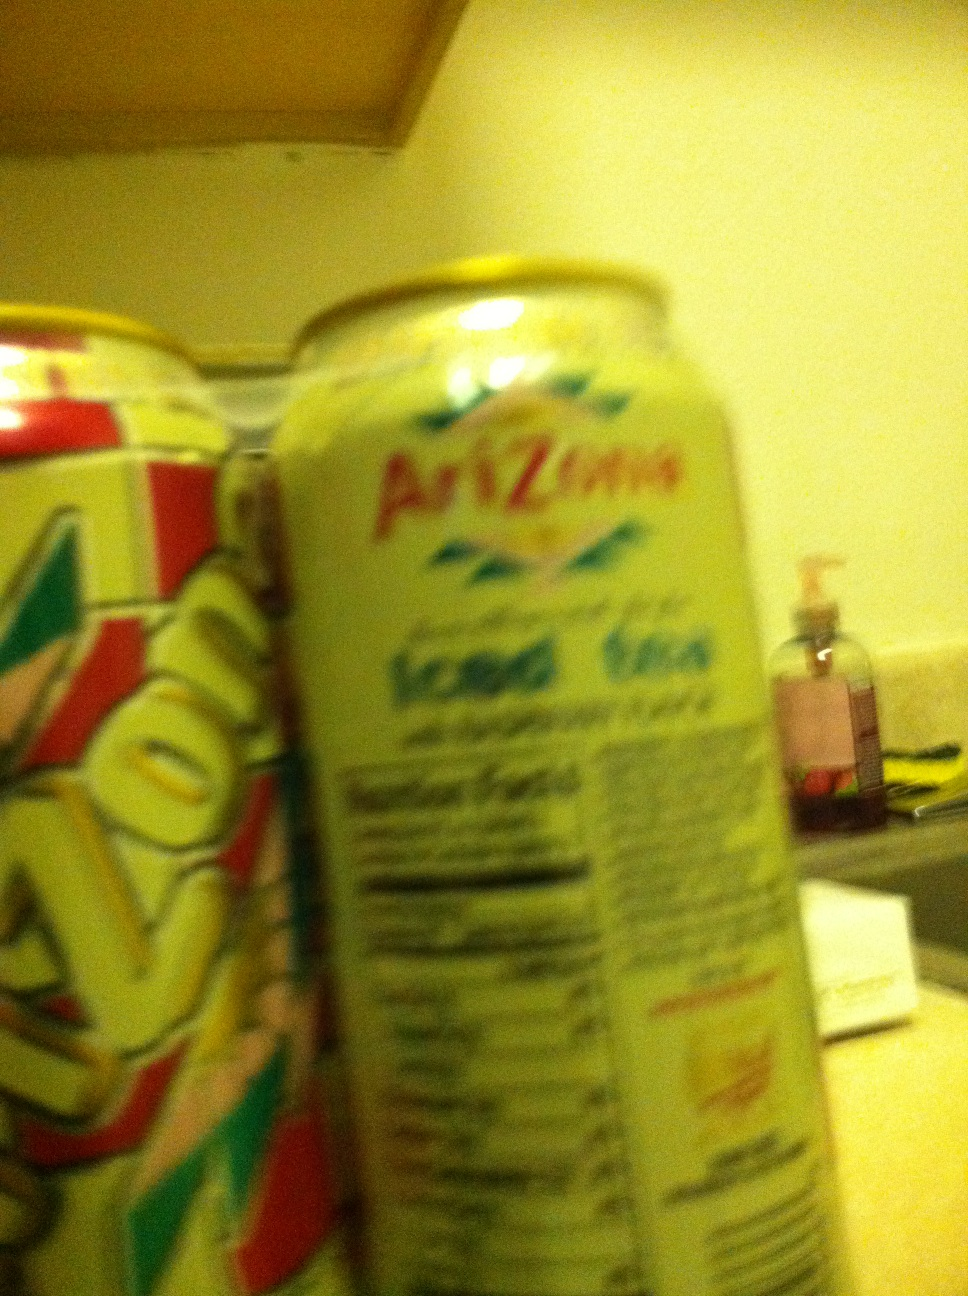Can you identify this beyond telling me that it is Arizona tea? Because, they've got about a million different flavors and some people don't seem to realize that. Either that or I've got the labels facing the wrong way. Thanks. from Vizwiz The image shows a can of Arizona Iced Tea, specifically the 'Green Tea with Ginseng and Honey' flavor. This is identified from the visible parts of the label in the image, particularly the words 'Green Tea' and 'Ginseng'. Arizona makes numerous flavors, and this one is known for its subtle green tea flavor accompanied by a sweet note of honey and the health benefits ginseng is believed to provide. 